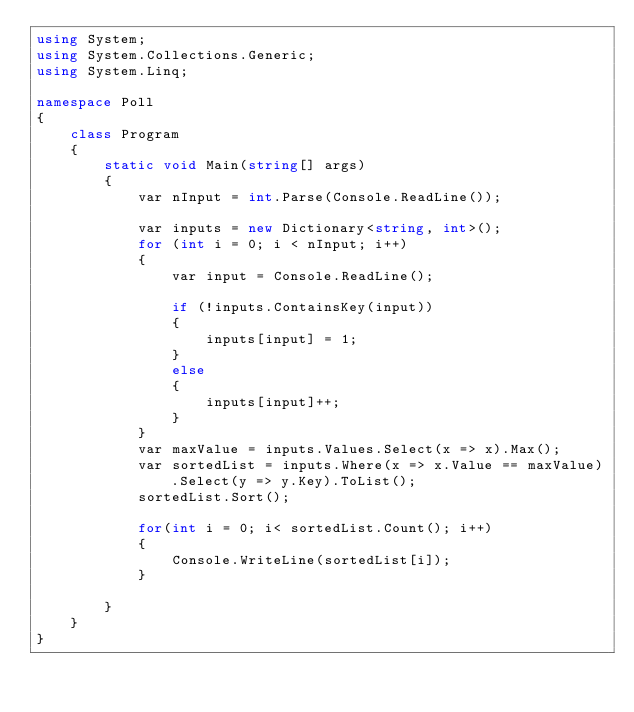<code> <loc_0><loc_0><loc_500><loc_500><_C#_>using System;
using System.Collections.Generic;
using System.Linq;

namespace Poll
{
    class Program
    {
        static void Main(string[] args)
        {
            var nInput = int.Parse(Console.ReadLine());
            
            var inputs = new Dictionary<string, int>();
            for (int i = 0; i < nInput; i++)
            {
                var input = Console.ReadLine();

                if (!inputs.ContainsKey(input))
                {
                    inputs[input] = 1;
                }
                else
                {
                    inputs[input]++;
                }
            }
            var maxValue = inputs.Values.Select(x => x).Max();                         
            var sortedList = inputs.Where(x => x.Value == maxValue).Select(y => y.Key).ToList();
            sortedList.Sort();

            for(int i = 0; i< sortedList.Count(); i++)
            {
                Console.WriteLine(sortedList[i]);
            }
                                       
        }
    }
}
</code> 